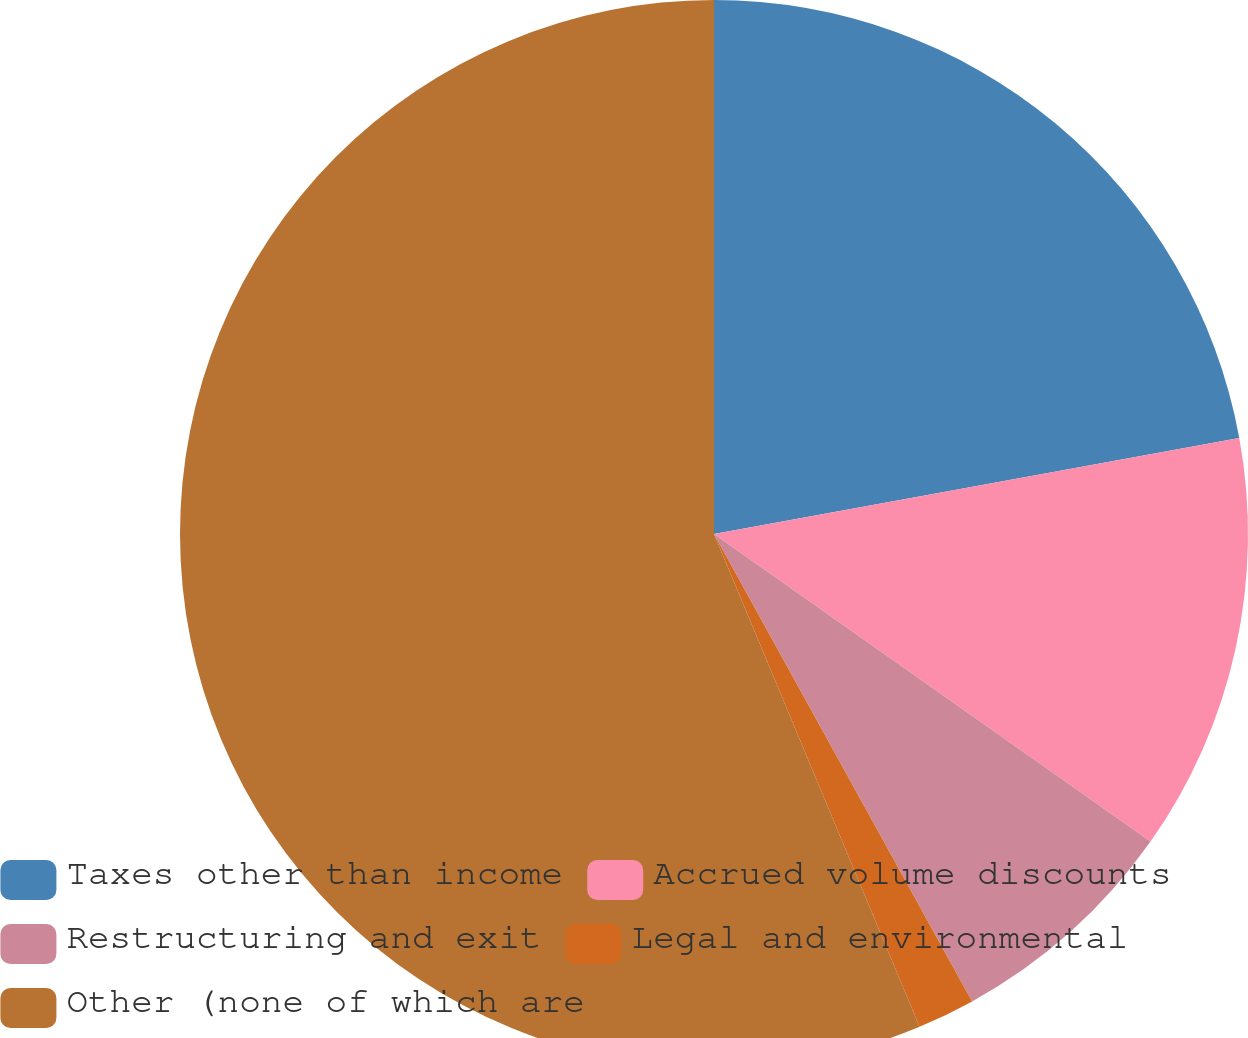Convert chart to OTSL. <chart><loc_0><loc_0><loc_500><loc_500><pie_chart><fcel>Taxes other than income<fcel>Accrued volume discounts<fcel>Restructuring and exit<fcel>Legal and environmental<fcel>Other (none of which are<nl><fcel>22.12%<fcel>12.65%<fcel>7.2%<fcel>1.74%<fcel>56.29%<nl></chart> 